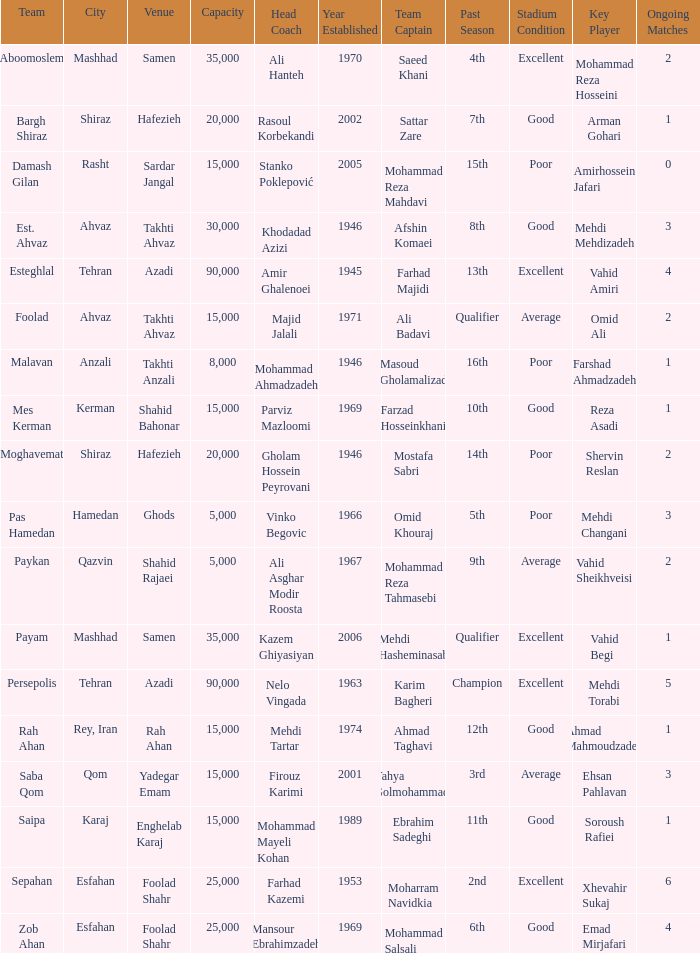What is the Capacity of the Venue of Head Coach Ali Asghar Modir Roosta? 5000.0. 